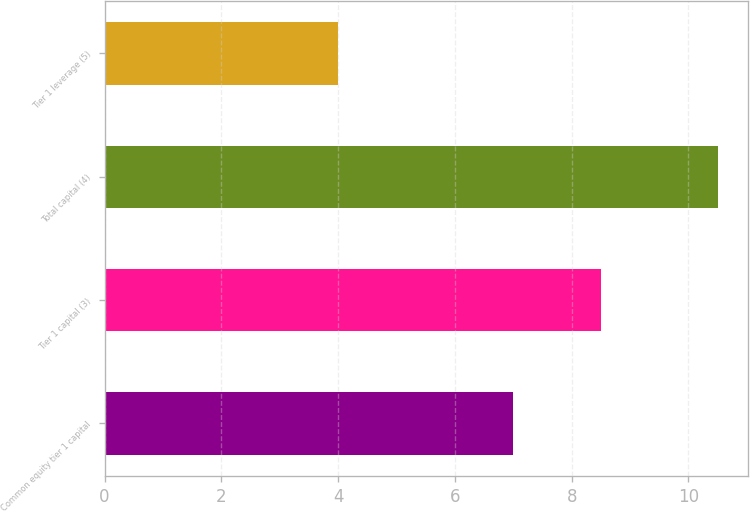Convert chart. <chart><loc_0><loc_0><loc_500><loc_500><bar_chart><fcel>Common equity tier 1 capital<fcel>Tier 1 capital (3)<fcel>Total capital (4)<fcel>Tier 1 leverage (5)<nl><fcel>7<fcel>8.5<fcel>10.5<fcel>4<nl></chart> 